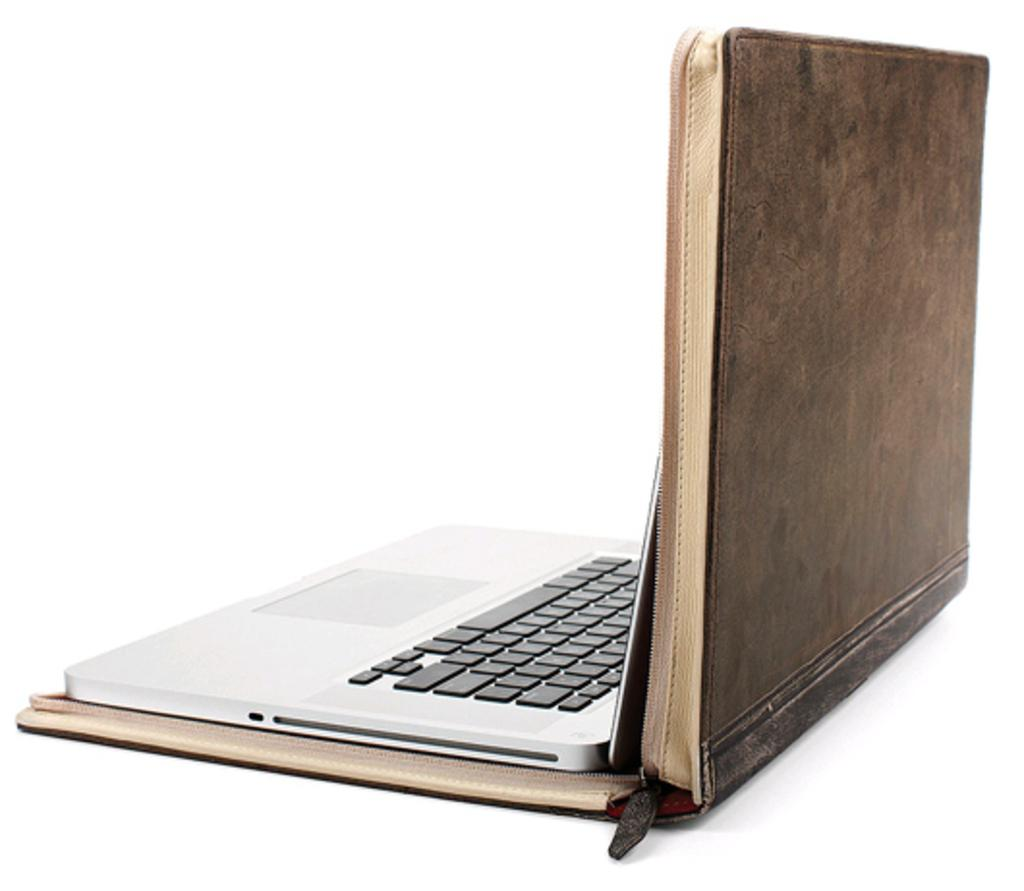What electronic device is visible in the image? There is a laptop in the image. What accessory is present for the laptop? There is a laptop bag in the image. On what surface are the laptop and laptop bag placed? The laptop and laptop bag are on a white surface. What type of farm animal can be seen lying on the bed in the image? There is no farm animal or bed present in the image; it features a laptop and laptop bag on a white surface. 